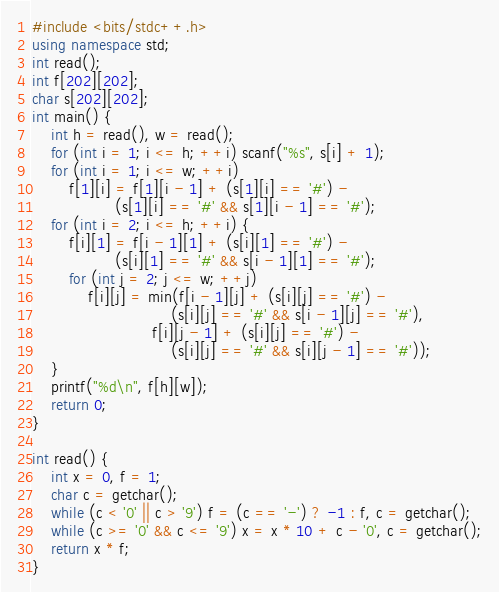<code> <loc_0><loc_0><loc_500><loc_500><_C++_>#include <bits/stdc++.h>
using namespace std;
int read();
int f[202][202];
char s[202][202];
int main() {
    int h = read(), w = read();
    for (int i = 1; i <= h; ++i) scanf("%s", s[i] + 1);
    for (int i = 1; i <= w; ++i)
        f[1][i] = f[1][i - 1] + (s[1][i] == '#') -
                  (s[1][i] == '#' && s[1][i - 1] == '#');
    for (int i = 2; i <= h; ++i) {
        f[i][1] = f[i - 1][1] + (s[i][1] == '#') -
                  (s[i][1] == '#' && s[i - 1][1] == '#');
        for (int j = 2; j <= w; ++j)
            f[i][j] = min(f[i - 1][j] + (s[i][j] == '#') -
                              (s[i][j] == '#' && s[i - 1][j] == '#'),
                          f[i][j - 1] + (s[i][j] == '#') -
                              (s[i][j] == '#' && s[i][j - 1] == '#'));
    }
    printf("%d\n", f[h][w]);
    return 0;
}

int read() {
    int x = 0, f = 1;
    char c = getchar();
    while (c < '0' || c > '9') f = (c == '-') ? -1 : f, c = getchar();
    while (c >= '0' && c <= '9') x = x * 10 + c - '0', c = getchar();
    return x * f;
}
</code> 